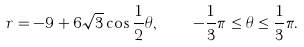Convert formula to latex. <formula><loc_0><loc_0><loc_500><loc_500>r = - 9 + 6 \sqrt { 3 } \cos \frac { 1 } { 2 } \theta , \quad - \frac { 1 } { 3 } \pi \leq \theta \leq \frac { 1 } { 3 } \pi .</formula> 